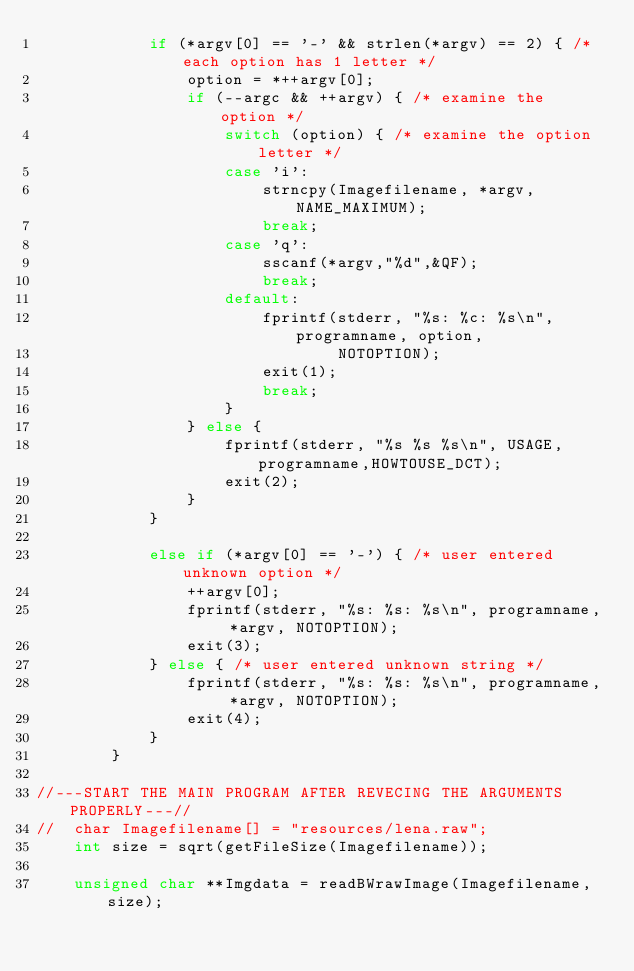<code> <loc_0><loc_0><loc_500><loc_500><_C++_>			if (*argv[0] == '-' && strlen(*argv) == 2) { /* each option has 1 letter */
				option = *++argv[0];
				if (--argc && ++argv) { /* examine the option */
					switch (option) { /* examine the option letter */
					case 'i':
						strncpy(Imagefilename, *argv, NAME_MAXIMUM);
						break;
					case 'q':
						sscanf(*argv,"%d",&QF);
						break;
					default:
						fprintf(stderr, "%s: %c: %s\n", programname, option,
								NOTOPTION);
						exit(1);
						break;
					}
				} else {
					fprintf(stderr, "%s %s %s\n", USAGE, programname,HOWTOUSE_DCT);
					exit(2);
				}
			}

			else if (*argv[0] == '-') { /* user entered unknown option */
				++argv[0];
				fprintf(stderr, "%s: %s: %s\n", programname, *argv, NOTOPTION);
				exit(3);
			} else { /* user entered unknown string */
				fprintf(stderr, "%s: %s: %s\n", programname, *argv, NOTOPTION);
				exit(4);
			}
		}

//---START THE MAIN PROGRAM AFTER REVECING THE ARGUMENTS PROPERLY---//
//	char Imagefilename[] = "resources/lena.raw";
	int size = sqrt(getFileSize(Imagefilename));

	unsigned char **Imgdata = readBWrawImage(Imagefilename, size);</code> 